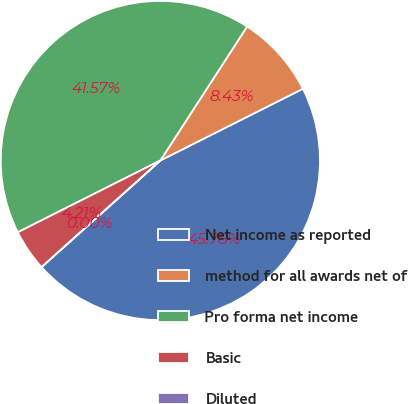Convert chart to OTSL. <chart><loc_0><loc_0><loc_500><loc_500><pie_chart><fcel>Net income as reported<fcel>method for all awards net of<fcel>Pro forma net income<fcel>Basic<fcel>Diluted<nl><fcel>45.78%<fcel>8.43%<fcel>41.57%<fcel>4.21%<fcel>0.0%<nl></chart> 